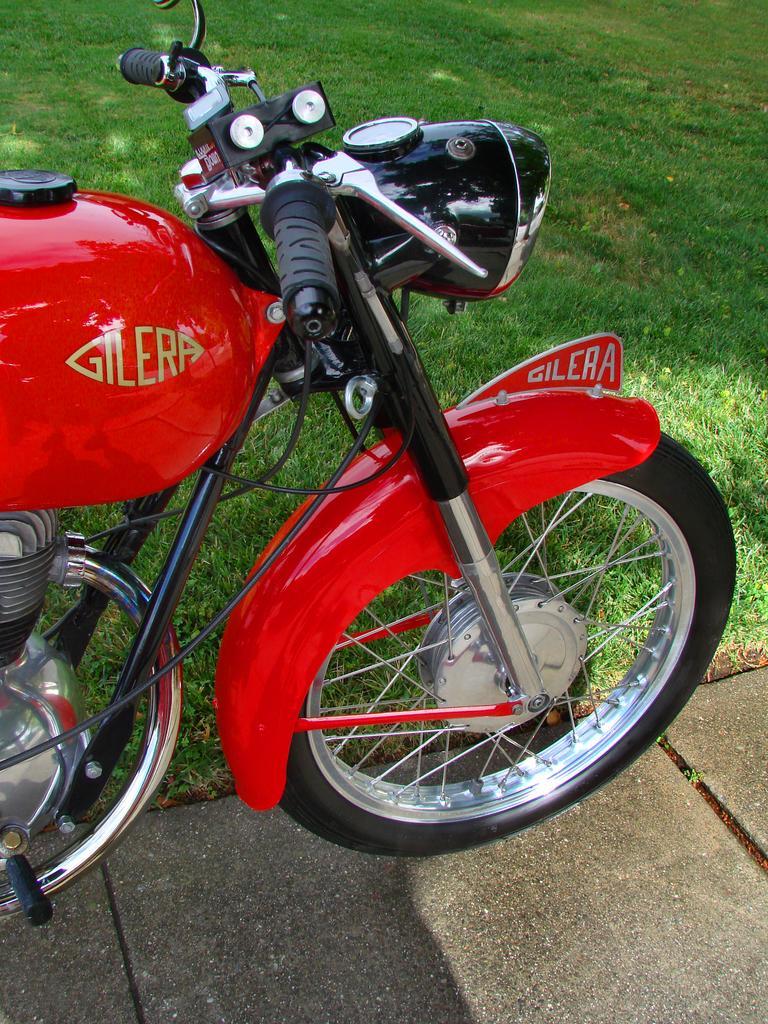Can you describe this image briefly? In this picture we can see a bike on the ground and in the background we can see grass. 